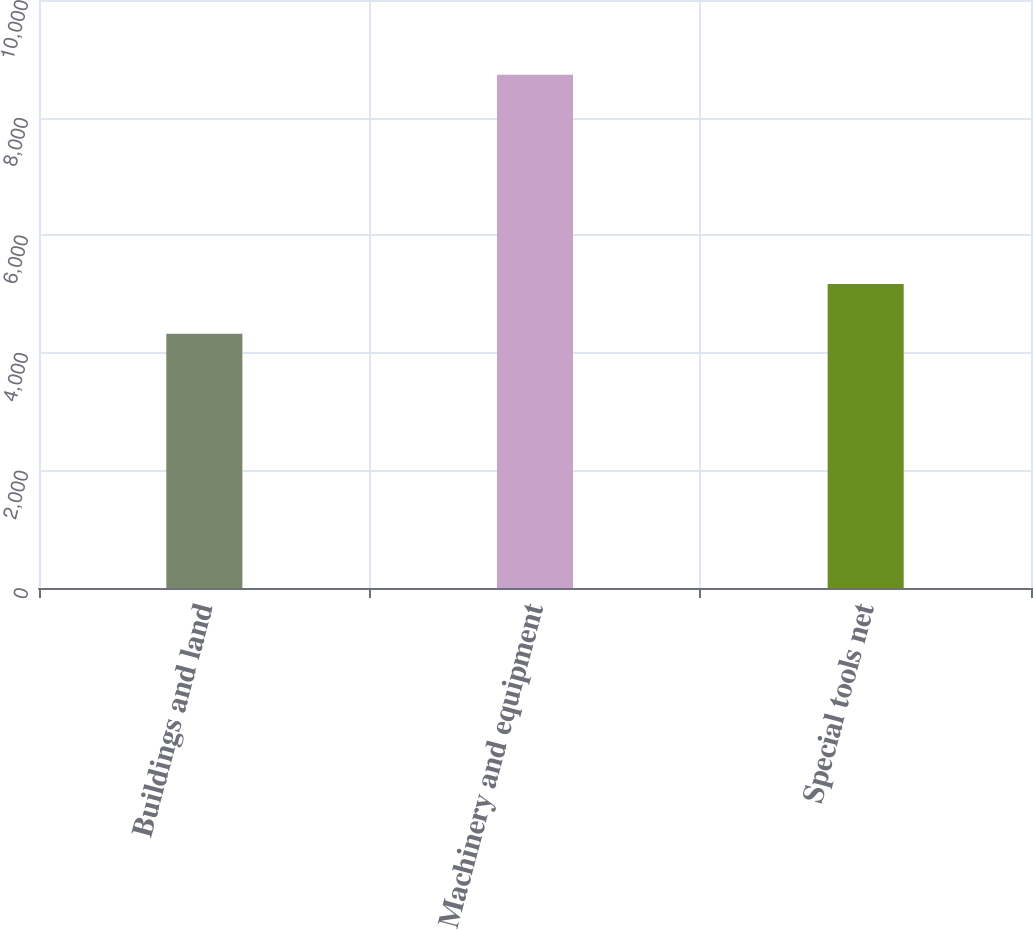Convert chart to OTSL. <chart><loc_0><loc_0><loc_500><loc_500><bar_chart><fcel>Buildings and land<fcel>Machinery and equipment<fcel>Special tools net<nl><fcel>4324<fcel>8727<fcel>5171<nl></chart> 